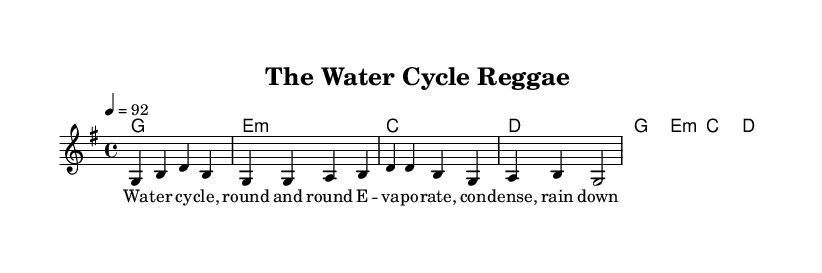What is the key signature of this music? The key signature is G major, which has one sharp (F#). You can identify it from the music notation in the top section which indicates the key.
Answer: G major What is the time signature of this music? The time signature is 4/4, which means there are four beats in each measure. This is shown at the beginning of the piece, indicated right after the key signature.
Answer: 4/4 What is the tempo marking in this music? The tempo marking is quarter note equals 92, indicating the speed of the music. You can find this in the tempo indication at the start of the piece, usually denoted with "4 = 92".
Answer: 92 What is the first chord in the piece? The first chord in the piece is G major, shown in the chord names section at the beginning. It is notated in the chord line corresponding to the first measure.
Answer: G How many measures are there in the melody section? There are 4 measures in the melody section, which can be counted by looking at the rhythmic notation since each measure is separated by a vertical line.
Answer: 4 What theme does the lyrics focus on in this reggae tune? The lyrics focus on the water cycle, which is explicitly stated in the verse lyrics. You can see the words clearly written beneath the melody notes relating to this educational theme.
Answer: Water cycle What unique rhythm characteristic is commonly found in reggae music reflected in this piece? The unique rhythm characteristic is the emphasis on the off-beat or backbeat which gives reggae its distinctive feel. This comes from how the melody and chords are structured, creating a laid-back groove typical of reggae tunes.
Answer: Off-beat 